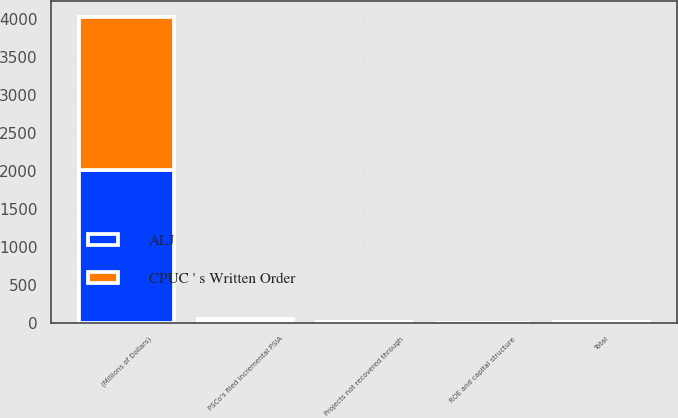Convert chart to OTSL. <chart><loc_0><loc_0><loc_500><loc_500><stacked_bar_chart><ecel><fcel>(Millions of Dollars)<fcel>PSCo's filed incremental PSIA<fcel>Projects not recovered through<fcel>ROE and capital structure<fcel>Total<nl><fcel>CPUC ' s Written Order<fcel>2016<fcel>21.7<fcel>3.6<fcel>0.3<fcel>7<nl><fcel>ALJ<fcel>2016<fcel>21.7<fcel>3.3<fcel>0.3<fcel>6.7<nl></chart> 